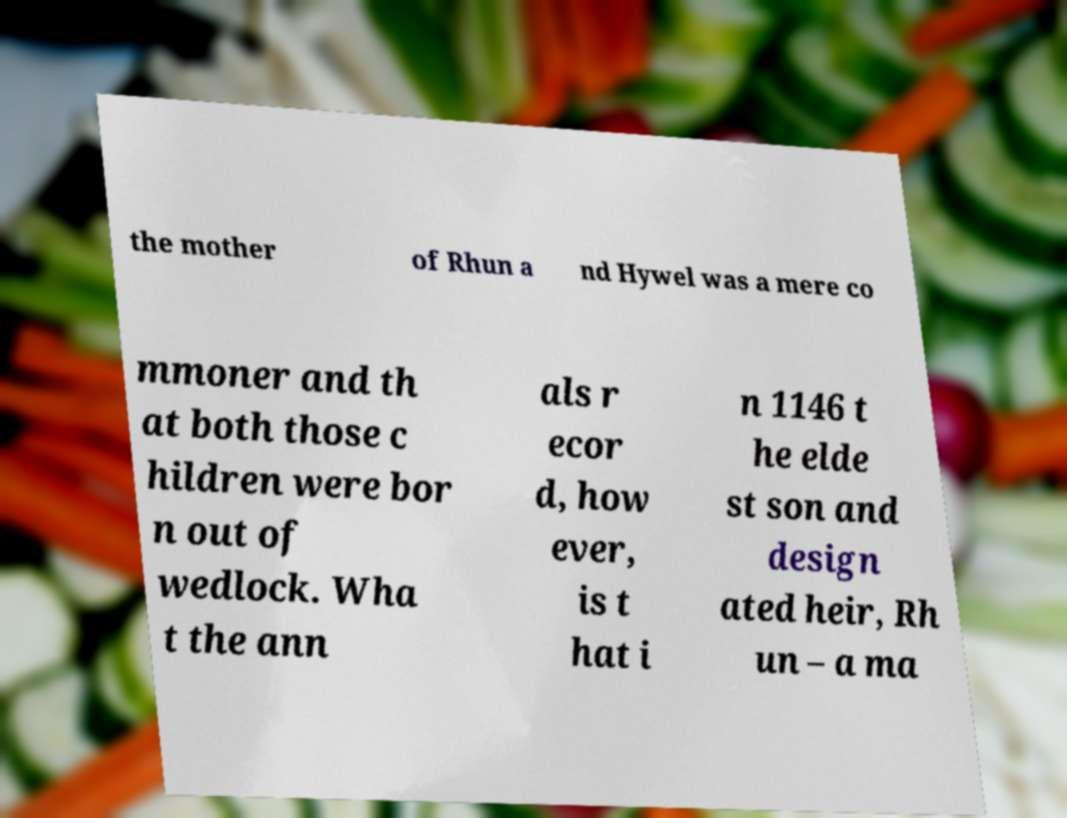Please identify and transcribe the text found in this image. the mother of Rhun a nd Hywel was a mere co mmoner and th at both those c hildren were bor n out of wedlock. Wha t the ann als r ecor d, how ever, is t hat i n 1146 t he elde st son and design ated heir, Rh un – a ma 